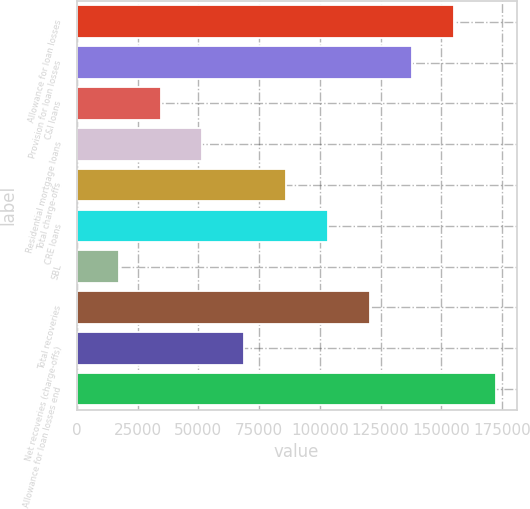<chart> <loc_0><loc_0><loc_500><loc_500><bar_chart><fcel>Allowance for loan losses<fcel>Provision for loan losses<fcel>C&I loans<fcel>Residential mortgage loans<fcel>Total charge-offs<fcel>CRE loans<fcel>SBL<fcel>Total recoveries<fcel>Net recoveries (charge-offs)<fcel>Allowance for loan losses end<nl><fcel>155031<fcel>137806<fcel>34452.5<fcel>51678<fcel>86129.2<fcel>103355<fcel>17226.9<fcel>120580<fcel>68903.6<fcel>172257<nl></chart> 